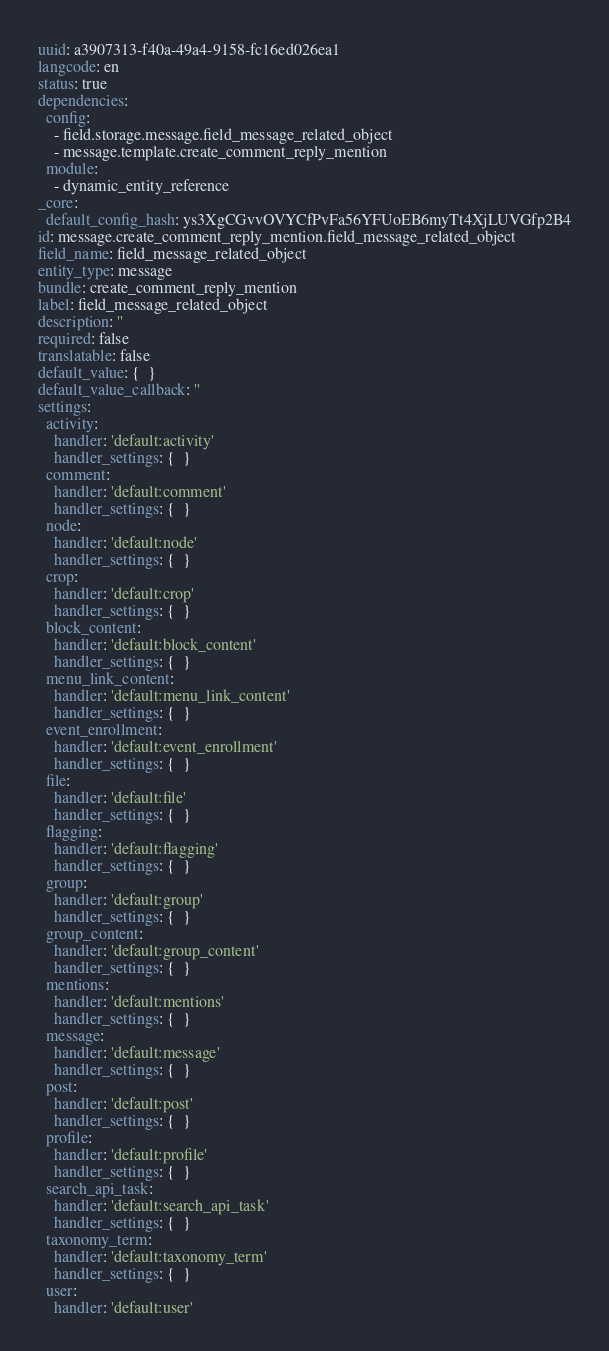<code> <loc_0><loc_0><loc_500><loc_500><_YAML_>uuid: a3907313-f40a-49a4-9158-fc16ed026ea1
langcode: en
status: true
dependencies:
  config:
    - field.storage.message.field_message_related_object
    - message.template.create_comment_reply_mention
  module:
    - dynamic_entity_reference
_core:
  default_config_hash: ys3XgCGvvOVYCfPvFa56YFUoEB6myTt4XjLUVGfp2B4
id: message.create_comment_reply_mention.field_message_related_object
field_name: field_message_related_object
entity_type: message
bundle: create_comment_reply_mention
label: field_message_related_object
description: ''
required: false
translatable: false
default_value: {  }
default_value_callback: ''
settings:
  activity:
    handler: 'default:activity'
    handler_settings: {  }
  comment:
    handler: 'default:comment'
    handler_settings: {  }
  node:
    handler: 'default:node'
    handler_settings: {  }
  crop:
    handler: 'default:crop'
    handler_settings: {  }
  block_content:
    handler: 'default:block_content'
    handler_settings: {  }
  menu_link_content:
    handler: 'default:menu_link_content'
    handler_settings: {  }
  event_enrollment:
    handler: 'default:event_enrollment'
    handler_settings: {  }
  file:
    handler: 'default:file'
    handler_settings: {  }
  flagging:
    handler: 'default:flagging'
    handler_settings: {  }
  group:
    handler: 'default:group'
    handler_settings: {  }
  group_content:
    handler: 'default:group_content'
    handler_settings: {  }
  mentions:
    handler: 'default:mentions'
    handler_settings: {  }
  message:
    handler: 'default:message'
    handler_settings: {  }
  post:
    handler: 'default:post'
    handler_settings: {  }
  profile:
    handler: 'default:profile'
    handler_settings: {  }
  search_api_task:
    handler: 'default:search_api_task'
    handler_settings: {  }
  taxonomy_term:
    handler: 'default:taxonomy_term'
    handler_settings: {  }
  user:
    handler: 'default:user'</code> 